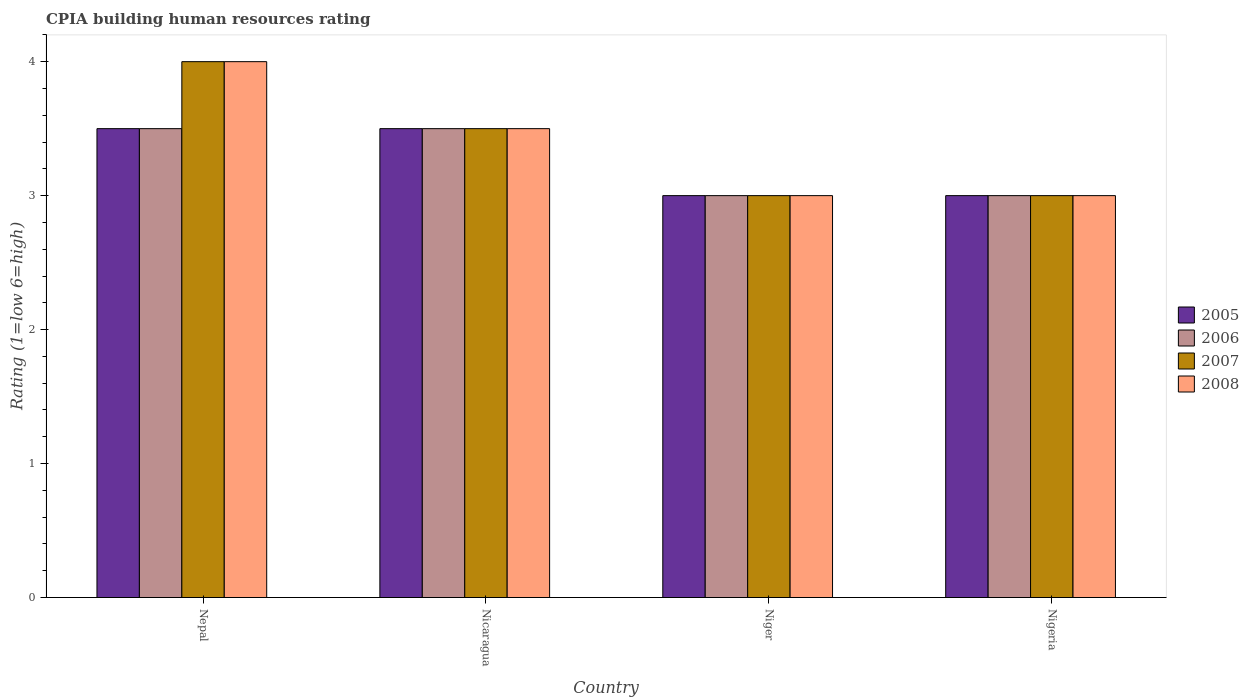Are the number of bars per tick equal to the number of legend labels?
Offer a terse response. Yes. Are the number of bars on each tick of the X-axis equal?
Your answer should be very brief. Yes. What is the label of the 2nd group of bars from the left?
Provide a short and direct response. Nicaragua. What is the CPIA rating in 2008 in Nigeria?
Ensure brevity in your answer.  3. Across all countries, what is the maximum CPIA rating in 2007?
Keep it short and to the point. 4. Across all countries, what is the minimum CPIA rating in 2008?
Ensure brevity in your answer.  3. In which country was the CPIA rating in 2006 maximum?
Your answer should be compact. Nepal. In which country was the CPIA rating in 2005 minimum?
Your answer should be compact. Niger. What is the total CPIA rating in 2006 in the graph?
Give a very brief answer. 13. What is the difference between the CPIA rating in 2008 in Nicaragua and that in Nigeria?
Provide a succinct answer. 0.5. What is the average CPIA rating in 2007 per country?
Provide a succinct answer. 3.38. What is the ratio of the CPIA rating in 2005 in Nicaragua to that in Nigeria?
Your answer should be compact. 1.17. Is the sum of the CPIA rating in 2006 in Niger and Nigeria greater than the maximum CPIA rating in 2008 across all countries?
Your answer should be very brief. Yes. What does the 2nd bar from the right in Niger represents?
Provide a succinct answer. 2007. Are the values on the major ticks of Y-axis written in scientific E-notation?
Your answer should be compact. No. Where does the legend appear in the graph?
Make the answer very short. Center right. How are the legend labels stacked?
Ensure brevity in your answer.  Vertical. What is the title of the graph?
Keep it short and to the point. CPIA building human resources rating. Does "1993" appear as one of the legend labels in the graph?
Offer a very short reply. No. What is the label or title of the Y-axis?
Provide a succinct answer. Rating (1=low 6=high). What is the Rating (1=low 6=high) of 2006 in Nepal?
Provide a succinct answer. 3.5. What is the Rating (1=low 6=high) in 2007 in Nepal?
Provide a succinct answer. 4. What is the Rating (1=low 6=high) in 2006 in Niger?
Offer a terse response. 3. What is the Rating (1=low 6=high) in 2007 in Niger?
Ensure brevity in your answer.  3. What is the Rating (1=low 6=high) of 2006 in Nigeria?
Keep it short and to the point. 3. What is the Rating (1=low 6=high) of 2007 in Nigeria?
Keep it short and to the point. 3. What is the Rating (1=low 6=high) in 2008 in Nigeria?
Make the answer very short. 3. Across all countries, what is the maximum Rating (1=low 6=high) of 2005?
Keep it short and to the point. 3.5. Across all countries, what is the maximum Rating (1=low 6=high) of 2006?
Offer a terse response. 3.5. Across all countries, what is the maximum Rating (1=low 6=high) in 2008?
Provide a succinct answer. 4. Across all countries, what is the minimum Rating (1=low 6=high) in 2008?
Make the answer very short. 3. What is the total Rating (1=low 6=high) in 2005 in the graph?
Your response must be concise. 13. What is the total Rating (1=low 6=high) of 2006 in the graph?
Offer a terse response. 13. What is the total Rating (1=low 6=high) of 2007 in the graph?
Your answer should be compact. 13.5. What is the total Rating (1=low 6=high) in 2008 in the graph?
Give a very brief answer. 13.5. What is the difference between the Rating (1=low 6=high) in 2006 in Nepal and that in Nicaragua?
Provide a succinct answer. 0. What is the difference between the Rating (1=low 6=high) in 2007 in Nepal and that in Nicaragua?
Offer a very short reply. 0.5. What is the difference between the Rating (1=low 6=high) in 2008 in Nepal and that in Nicaragua?
Your answer should be very brief. 0.5. What is the difference between the Rating (1=low 6=high) of 2005 in Nepal and that in Niger?
Ensure brevity in your answer.  0.5. What is the difference between the Rating (1=low 6=high) in 2006 in Nepal and that in Niger?
Provide a short and direct response. 0.5. What is the difference between the Rating (1=low 6=high) in 2008 in Nepal and that in Niger?
Give a very brief answer. 1. What is the difference between the Rating (1=low 6=high) of 2005 in Nepal and that in Nigeria?
Give a very brief answer. 0.5. What is the difference between the Rating (1=low 6=high) of 2008 in Nepal and that in Nigeria?
Your response must be concise. 1. What is the difference between the Rating (1=low 6=high) of 2005 in Nicaragua and that in Niger?
Your response must be concise. 0.5. What is the difference between the Rating (1=low 6=high) of 2006 in Nicaragua and that in Niger?
Offer a terse response. 0.5. What is the difference between the Rating (1=low 6=high) of 2008 in Nicaragua and that in Niger?
Your answer should be very brief. 0.5. What is the difference between the Rating (1=low 6=high) in 2007 in Nicaragua and that in Nigeria?
Give a very brief answer. 0.5. What is the difference between the Rating (1=low 6=high) of 2008 in Nicaragua and that in Nigeria?
Provide a short and direct response. 0.5. What is the difference between the Rating (1=low 6=high) of 2006 in Niger and that in Nigeria?
Provide a succinct answer. 0. What is the difference between the Rating (1=low 6=high) of 2005 in Nepal and the Rating (1=low 6=high) of 2006 in Nicaragua?
Provide a short and direct response. 0. What is the difference between the Rating (1=low 6=high) in 2005 in Nepal and the Rating (1=low 6=high) in 2008 in Nicaragua?
Offer a terse response. 0. What is the difference between the Rating (1=low 6=high) in 2005 in Nepal and the Rating (1=low 6=high) in 2006 in Niger?
Make the answer very short. 0.5. What is the difference between the Rating (1=low 6=high) of 2005 in Nepal and the Rating (1=low 6=high) of 2007 in Niger?
Provide a short and direct response. 0.5. What is the difference between the Rating (1=low 6=high) in 2005 in Nepal and the Rating (1=low 6=high) in 2008 in Niger?
Your response must be concise. 0.5. What is the difference between the Rating (1=low 6=high) in 2006 in Nepal and the Rating (1=low 6=high) in 2007 in Niger?
Provide a succinct answer. 0.5. What is the difference between the Rating (1=low 6=high) in 2006 in Nepal and the Rating (1=low 6=high) in 2008 in Niger?
Your response must be concise. 0.5. What is the difference between the Rating (1=low 6=high) in 2005 in Nepal and the Rating (1=low 6=high) in 2007 in Nigeria?
Keep it short and to the point. 0.5. What is the difference between the Rating (1=low 6=high) in 2006 in Nepal and the Rating (1=low 6=high) in 2008 in Nigeria?
Keep it short and to the point. 0.5. What is the difference between the Rating (1=low 6=high) in 2006 in Nicaragua and the Rating (1=low 6=high) in 2008 in Niger?
Offer a very short reply. 0.5. What is the difference between the Rating (1=low 6=high) of 2007 in Nicaragua and the Rating (1=low 6=high) of 2008 in Niger?
Your answer should be very brief. 0.5. What is the difference between the Rating (1=low 6=high) of 2005 in Nicaragua and the Rating (1=low 6=high) of 2007 in Nigeria?
Offer a very short reply. 0.5. What is the difference between the Rating (1=low 6=high) of 2005 in Nicaragua and the Rating (1=low 6=high) of 2008 in Nigeria?
Ensure brevity in your answer.  0.5. What is the difference between the Rating (1=low 6=high) of 2006 in Nicaragua and the Rating (1=low 6=high) of 2008 in Nigeria?
Keep it short and to the point. 0.5. What is the difference between the Rating (1=low 6=high) of 2005 in Niger and the Rating (1=low 6=high) of 2007 in Nigeria?
Offer a very short reply. 0. What is the difference between the Rating (1=low 6=high) in 2006 in Niger and the Rating (1=low 6=high) in 2007 in Nigeria?
Ensure brevity in your answer.  0. What is the difference between the Rating (1=low 6=high) in 2006 in Niger and the Rating (1=low 6=high) in 2008 in Nigeria?
Provide a short and direct response. 0. What is the average Rating (1=low 6=high) in 2005 per country?
Provide a short and direct response. 3.25. What is the average Rating (1=low 6=high) in 2007 per country?
Keep it short and to the point. 3.38. What is the average Rating (1=low 6=high) in 2008 per country?
Your answer should be very brief. 3.38. What is the difference between the Rating (1=low 6=high) in 2005 and Rating (1=low 6=high) in 2007 in Nepal?
Your answer should be very brief. -0.5. What is the difference between the Rating (1=low 6=high) in 2006 and Rating (1=low 6=high) in 2008 in Nepal?
Your answer should be very brief. -0.5. What is the difference between the Rating (1=low 6=high) in 2007 and Rating (1=low 6=high) in 2008 in Nepal?
Give a very brief answer. 0. What is the difference between the Rating (1=low 6=high) in 2005 and Rating (1=low 6=high) in 2006 in Nicaragua?
Provide a short and direct response. 0. What is the difference between the Rating (1=low 6=high) in 2005 and Rating (1=low 6=high) in 2007 in Nicaragua?
Ensure brevity in your answer.  0. What is the difference between the Rating (1=low 6=high) in 2005 and Rating (1=low 6=high) in 2008 in Nicaragua?
Make the answer very short. 0. What is the difference between the Rating (1=low 6=high) of 2006 and Rating (1=low 6=high) of 2007 in Nicaragua?
Provide a succinct answer. 0. What is the difference between the Rating (1=low 6=high) in 2006 and Rating (1=low 6=high) in 2008 in Nicaragua?
Offer a terse response. 0. What is the difference between the Rating (1=low 6=high) of 2005 and Rating (1=low 6=high) of 2006 in Niger?
Keep it short and to the point. 0. What is the difference between the Rating (1=low 6=high) in 2006 and Rating (1=low 6=high) in 2007 in Niger?
Your answer should be compact. 0. What is the difference between the Rating (1=low 6=high) in 2006 and Rating (1=low 6=high) in 2008 in Niger?
Provide a short and direct response. 0. What is the difference between the Rating (1=low 6=high) of 2005 and Rating (1=low 6=high) of 2006 in Nigeria?
Ensure brevity in your answer.  0. What is the difference between the Rating (1=low 6=high) of 2005 and Rating (1=low 6=high) of 2007 in Nigeria?
Make the answer very short. 0. What is the difference between the Rating (1=low 6=high) of 2006 and Rating (1=low 6=high) of 2008 in Nigeria?
Offer a very short reply. 0. What is the difference between the Rating (1=low 6=high) in 2007 and Rating (1=low 6=high) in 2008 in Nigeria?
Your answer should be compact. 0. What is the ratio of the Rating (1=low 6=high) in 2005 in Nepal to that in Nicaragua?
Provide a short and direct response. 1. What is the ratio of the Rating (1=low 6=high) in 2007 in Nepal to that in Nicaragua?
Provide a succinct answer. 1.14. What is the ratio of the Rating (1=low 6=high) in 2008 in Nepal to that in Nicaragua?
Your answer should be compact. 1.14. What is the ratio of the Rating (1=low 6=high) in 2005 in Nepal to that in Niger?
Your response must be concise. 1.17. What is the ratio of the Rating (1=low 6=high) in 2006 in Nepal to that in Niger?
Keep it short and to the point. 1.17. What is the ratio of the Rating (1=low 6=high) of 2008 in Nepal to that in Niger?
Make the answer very short. 1.33. What is the ratio of the Rating (1=low 6=high) of 2005 in Nepal to that in Nigeria?
Offer a very short reply. 1.17. What is the ratio of the Rating (1=low 6=high) in 2007 in Nepal to that in Nigeria?
Offer a terse response. 1.33. What is the ratio of the Rating (1=low 6=high) of 2008 in Nicaragua to that in Niger?
Provide a short and direct response. 1.17. What is the ratio of the Rating (1=low 6=high) in 2008 in Nicaragua to that in Nigeria?
Your response must be concise. 1.17. What is the ratio of the Rating (1=low 6=high) in 2007 in Niger to that in Nigeria?
Your answer should be very brief. 1. What is the ratio of the Rating (1=low 6=high) in 2008 in Niger to that in Nigeria?
Offer a very short reply. 1. What is the difference between the highest and the second highest Rating (1=low 6=high) in 2008?
Offer a terse response. 0.5. What is the difference between the highest and the lowest Rating (1=low 6=high) in 2005?
Your response must be concise. 0.5. What is the difference between the highest and the lowest Rating (1=low 6=high) in 2006?
Provide a succinct answer. 0.5. 